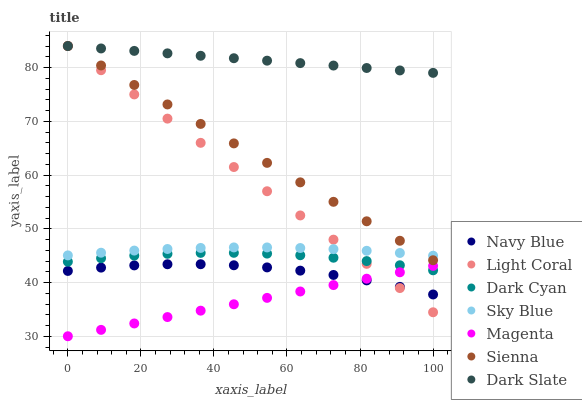Does Magenta have the minimum area under the curve?
Answer yes or no. Yes. Does Dark Slate have the maximum area under the curve?
Answer yes or no. Yes. Does Navy Blue have the minimum area under the curve?
Answer yes or no. No. Does Navy Blue have the maximum area under the curve?
Answer yes or no. No. Is Magenta the smoothest?
Answer yes or no. Yes. Is Navy Blue the roughest?
Answer yes or no. Yes. Is Light Coral the smoothest?
Answer yes or no. No. Is Light Coral the roughest?
Answer yes or no. No. Does Magenta have the lowest value?
Answer yes or no. Yes. Does Navy Blue have the lowest value?
Answer yes or no. No. Does Dark Slate have the highest value?
Answer yes or no. Yes. Does Navy Blue have the highest value?
Answer yes or no. No. Is Magenta less than Sky Blue?
Answer yes or no. Yes. Is Dark Cyan greater than Navy Blue?
Answer yes or no. Yes. Does Light Coral intersect Navy Blue?
Answer yes or no. Yes. Is Light Coral less than Navy Blue?
Answer yes or no. No. Is Light Coral greater than Navy Blue?
Answer yes or no. No. Does Magenta intersect Sky Blue?
Answer yes or no. No. 